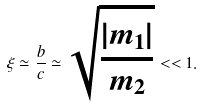<formula> <loc_0><loc_0><loc_500><loc_500>\xi \simeq \frac { b } { c } \simeq \sqrt { \frac { | m _ { 1 } | } { m _ { 2 } } } < < 1 .</formula> 